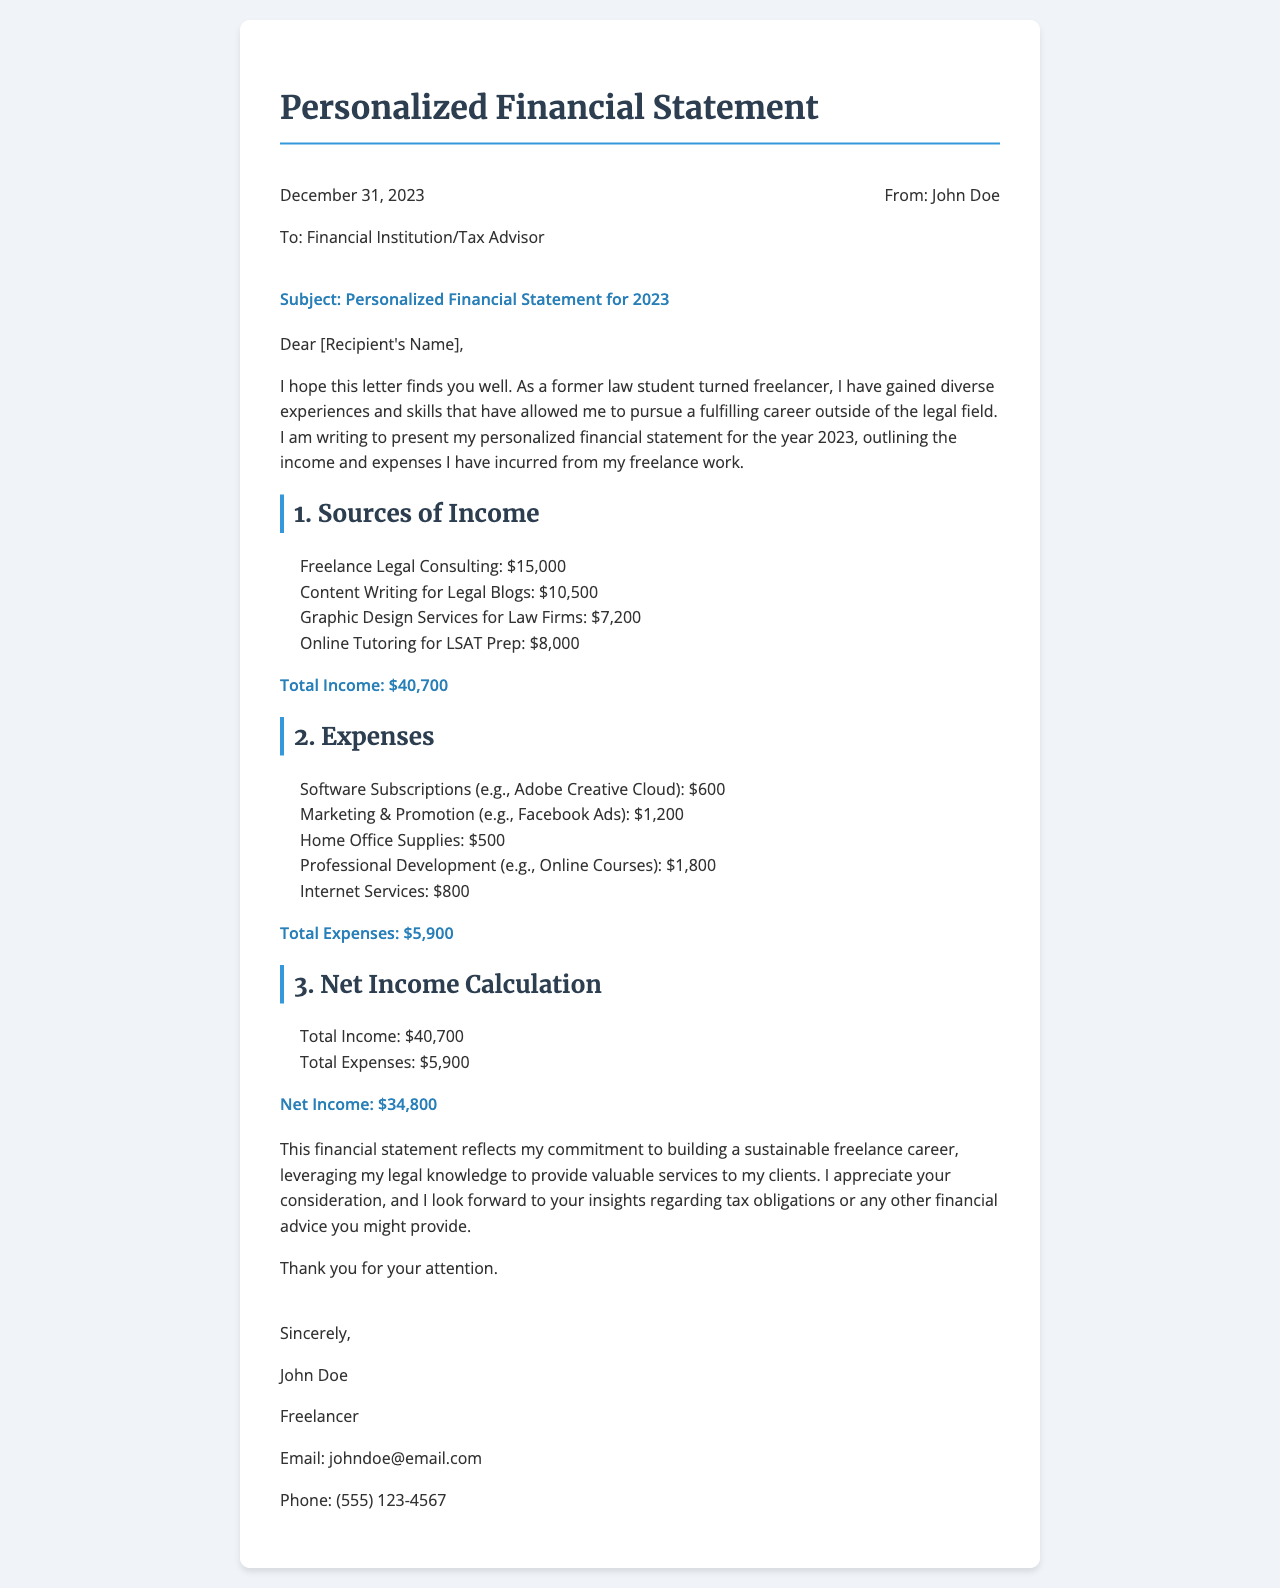What is the total income for 2023? The total income is stated in the document as the sum of all income sources, which is $15,000 + $10,500 + $7,200 + $8,000 = $40,700.
Answer: $40,700 What is the net income? The net income is calculated by subtracting total expenses from total income, which is $40,700 - $5,900 = $34,800.
Answer: $34,800 Which service generated the highest income? The highest income source is identified as Freelance Legal Consulting, which earned $15,000.
Answer: Freelance Legal Consulting What is the total amount spent on professional development? The amount spent on professional development is listed in the expenses as $1,800.
Answer: $1,800 What date is mentioned in the letter? The date mentioned in the letter is December 31, 2023.
Answer: December 31, 2023 What type of work does John Doe perform? The type of work performed is freelancing.
Answer: freelancing What is the total amount spent on software subscriptions? The expenses for software subscriptions are indicated to be $600.
Answer: $600 Who is the recipient of the letter? The recipient is addressed as Financial Institution/Tax Advisor.
Answer: Financial Institution/Tax Advisor What are the categories listed under Expenses? The categories under expenses include Software Subscriptions, Marketing & Promotion, Home Office Supplies, Professional Development, and Internet Services.
Answer: Software Subscriptions, Marketing & Promotion, Home Office Supplies, Professional Development, Internet Services 